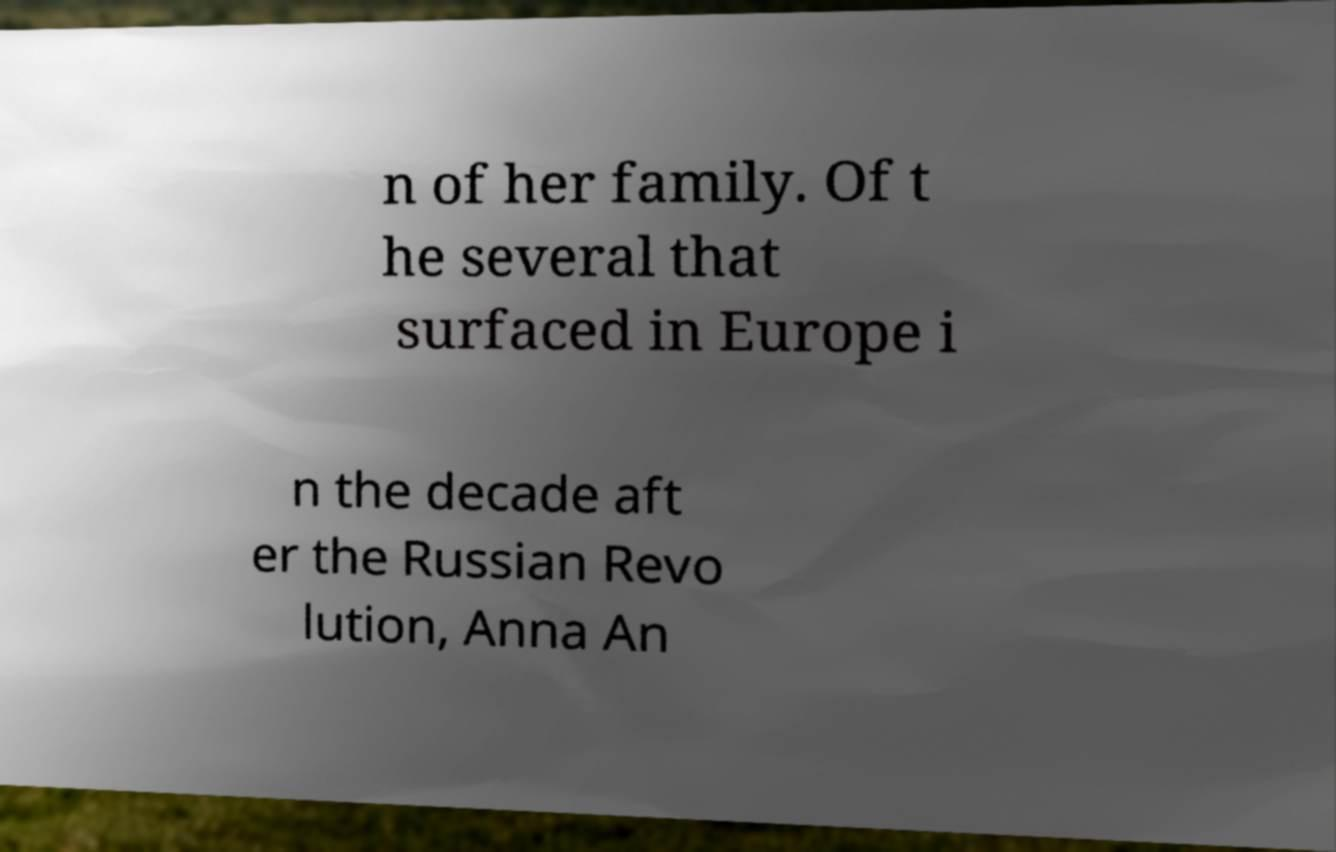What messages or text are displayed in this image? I need them in a readable, typed format. n of her family. Of t he several that surfaced in Europe i n the decade aft er the Russian Revo lution, Anna An 